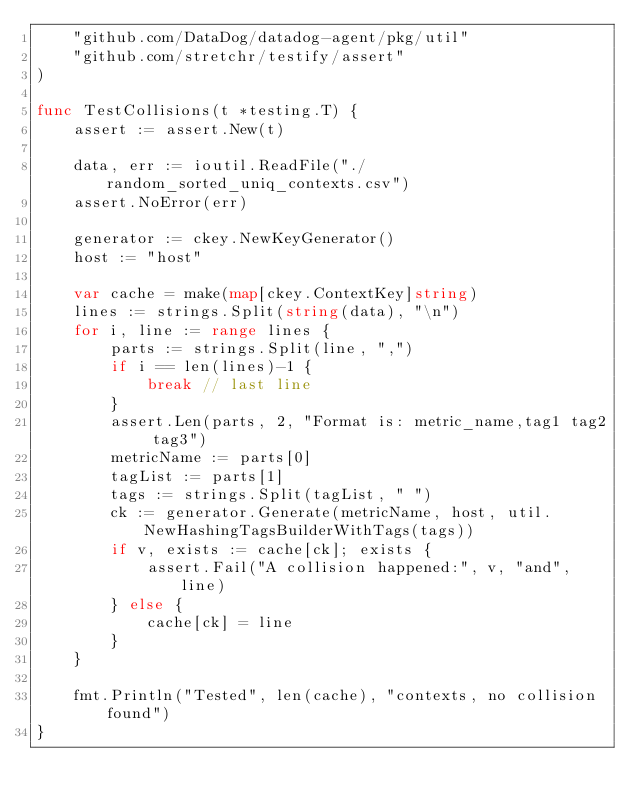Convert code to text. <code><loc_0><loc_0><loc_500><loc_500><_Go_>	"github.com/DataDog/datadog-agent/pkg/util"
	"github.com/stretchr/testify/assert"
)

func TestCollisions(t *testing.T) {
	assert := assert.New(t)

	data, err := ioutil.ReadFile("./random_sorted_uniq_contexts.csv")
	assert.NoError(err)

	generator := ckey.NewKeyGenerator()
	host := "host"

	var cache = make(map[ckey.ContextKey]string)
	lines := strings.Split(string(data), "\n")
	for i, line := range lines {
		parts := strings.Split(line, ",")
		if i == len(lines)-1 {
			break // last line
		}
		assert.Len(parts, 2, "Format is: metric_name,tag1 tag2 tag3")
		metricName := parts[0]
		tagList := parts[1]
		tags := strings.Split(tagList, " ")
		ck := generator.Generate(metricName, host, util.NewHashingTagsBuilderWithTags(tags))
		if v, exists := cache[ck]; exists {
			assert.Fail("A collision happened:", v, "and", line)
		} else {
			cache[ck] = line
		}
	}

	fmt.Println("Tested", len(cache), "contexts, no collision found")
}
</code> 